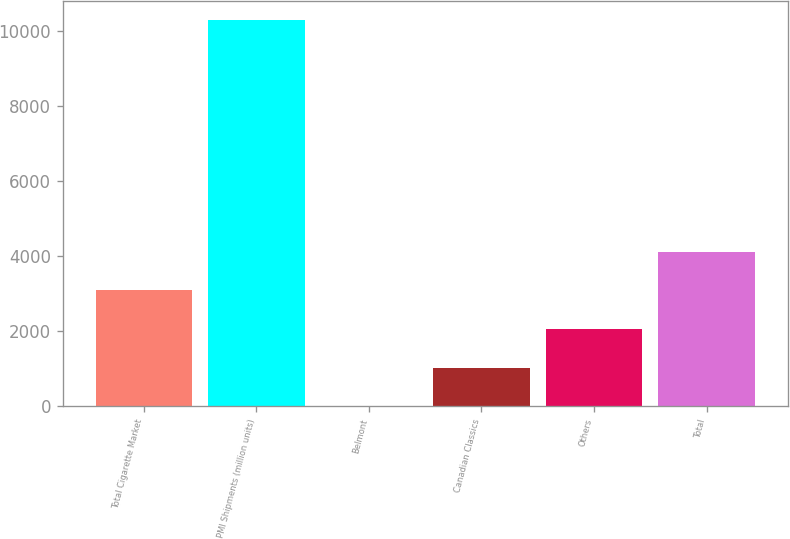Convert chart to OTSL. <chart><loc_0><loc_0><loc_500><loc_500><bar_chart><fcel>Total Cigarette Market<fcel>PMI Shipments (million units)<fcel>Belmont<fcel>Canadian Classics<fcel>Others<fcel>Total<nl><fcel>3084.6<fcel>10275<fcel>3<fcel>1030.2<fcel>2057.4<fcel>4111.8<nl></chart> 